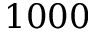Convert formula to latex. <formula><loc_0><loc_0><loc_500><loc_500>1 0 0 0</formula> 